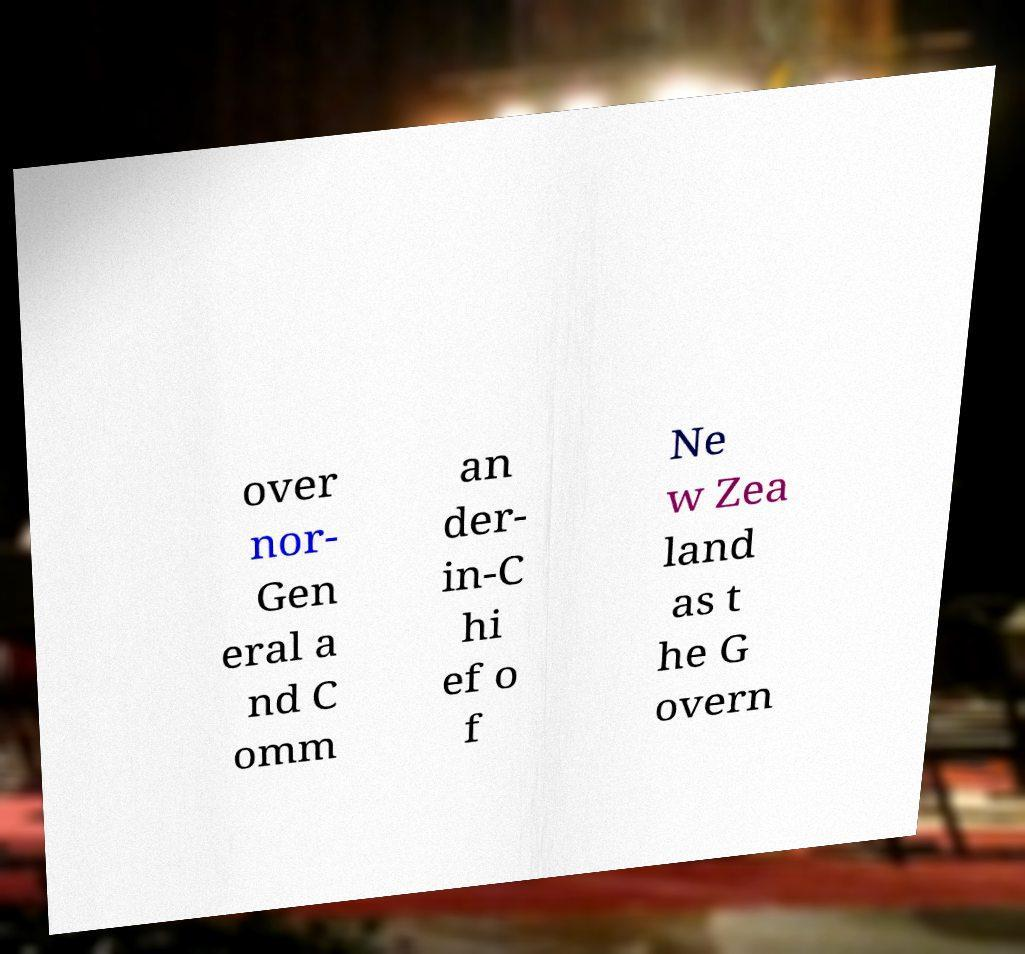Please identify and transcribe the text found in this image. over nor- Gen eral a nd C omm an der- in-C hi ef o f Ne w Zea land as t he G overn 